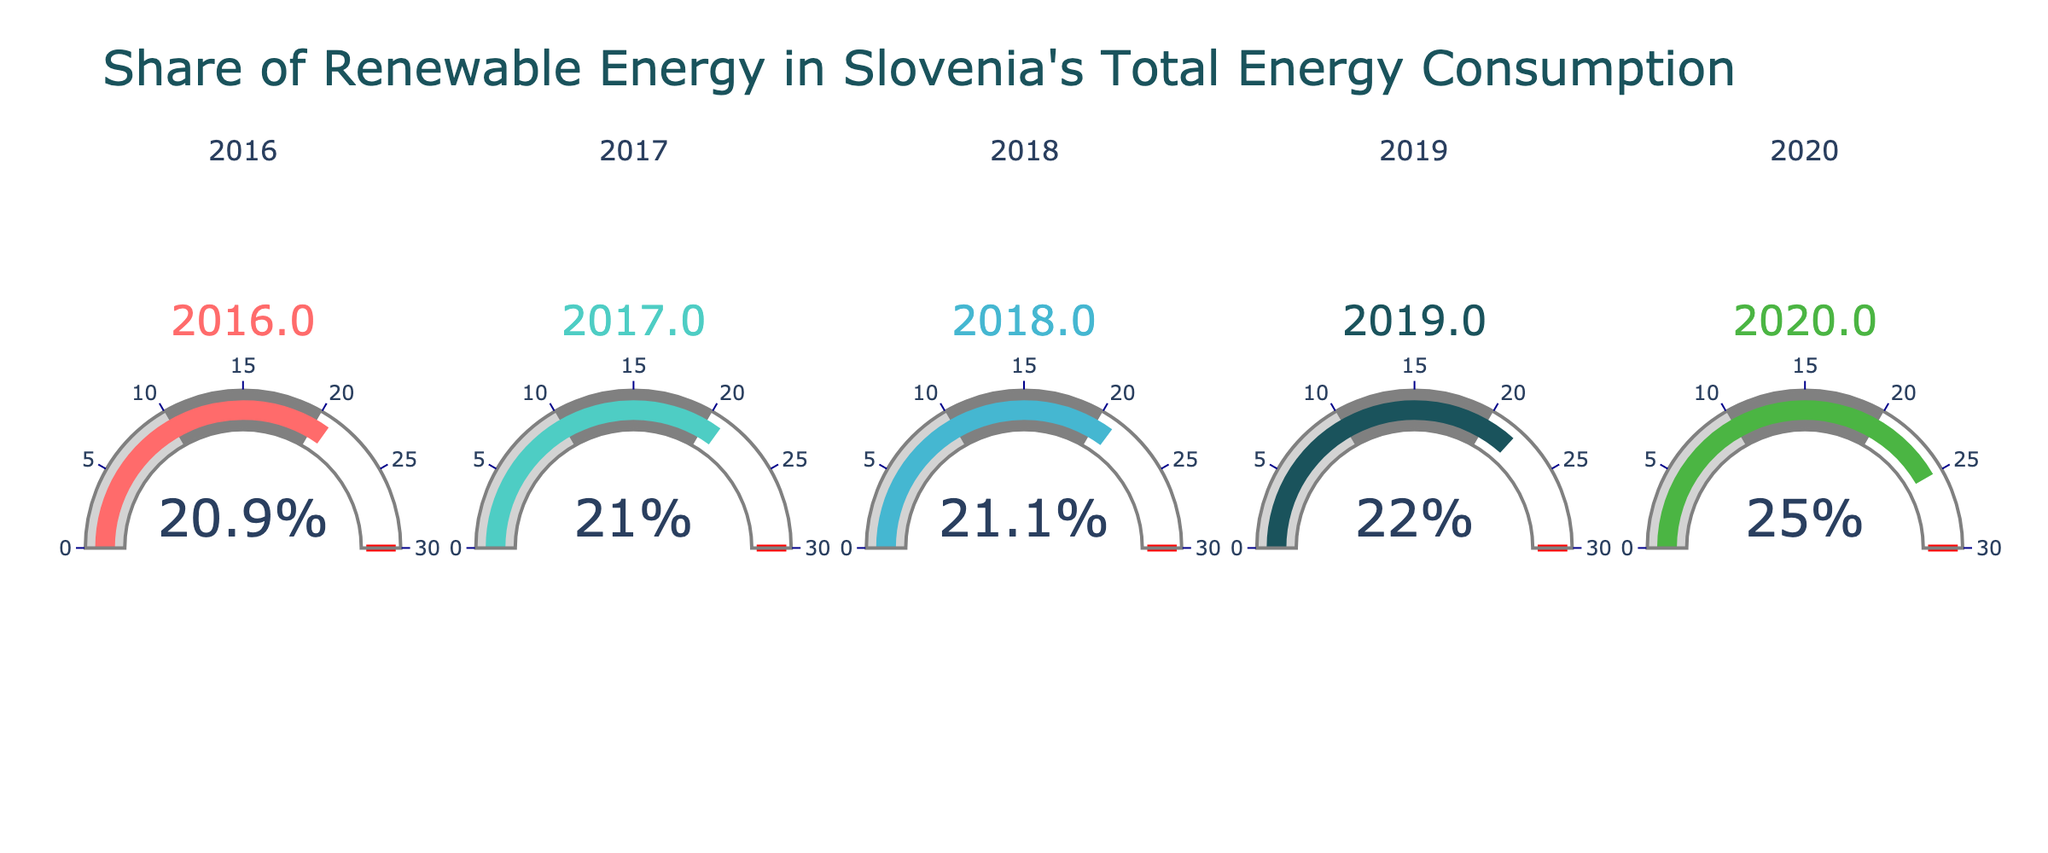What is the title of the figure? The title is located at the top of the figure and states the main subject being represented in the chart. In this case, it is about the share of renewable energy in Slovenia's total energy consumption.
Answer: Share of Renewable Energy in Slovenia's Total Energy Consumption What was the share of renewable energy in Slovenia in 2020? The gauge labeled "2020" provides this information in numerical format.
Answer: 25% Which year shows the lowest share of renewable energy? By comparing the numerical values on each gauge, we see that the year with the lowest share is labeled "2016".
Answer: 2016 What is the average share of renewable energy from 2016 to 2020? Sum values for each year (25% + 22% + 21.1% + 21% + 20.9%) and divide by the number of years (5). The calculation is (25 + 22 + 21.1 + 21 + 20.9) / 5.
Answer: 22% How did the share of renewable energy change from 2016 to 2020? Subtract the value for 2016 from the value for 2020 to determine the change. The calculation is 25% - 20.9%.
Answer: Increased by 4.1% Which year had the highest share of renewable energy? By examining all the gauges, the highest value is shown for the year labeled "2020".
Answer: 2020 What can you infer about the trend in renewable energy consumption over the years shown? Observing the gauges from 2016 to 2020, the values generally increase, indicating an overall positive trend in the share of renewable energy.
Answer: Increasing trend By how much did the share of renewable energy increase from 2019 to 2020? Subtract the value for 2019 from the value for 2020. The calculation is 25% - 22%.
Answer: 3% What is the difference in the renewable energy share between the year with the highest value and the year with the lowest value? Subtract the lowest value (2016, 20.9%) from the highest value (2020, 25%). The calculation is 25% - 20.9%.
Answer: 4.1% What is the cumulative share of renewable energy over the five years? Add up the values for all five years. The calculation is 25 + 22 + 21.1 + 21 + 20.9.
Answer: 110% 